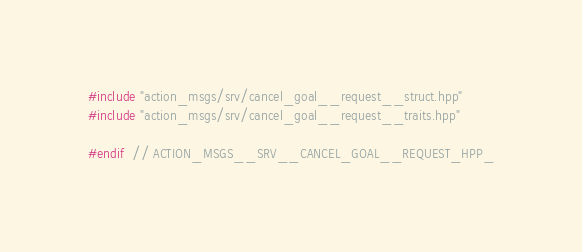Convert code to text. <code><loc_0><loc_0><loc_500><loc_500><_C++_>
#include "action_msgs/srv/cancel_goal__request__struct.hpp"
#include "action_msgs/srv/cancel_goal__request__traits.hpp"

#endif  // ACTION_MSGS__SRV__CANCEL_GOAL__REQUEST_HPP_
</code> 